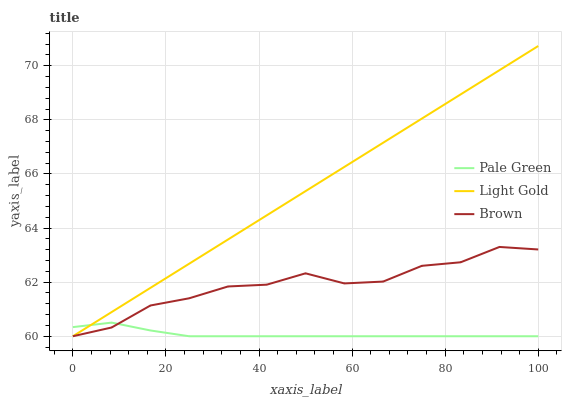Does Pale Green have the minimum area under the curve?
Answer yes or no. Yes. Does Light Gold have the maximum area under the curve?
Answer yes or no. Yes. Does Light Gold have the minimum area under the curve?
Answer yes or no. No. Does Pale Green have the maximum area under the curve?
Answer yes or no. No. Is Light Gold the smoothest?
Answer yes or no. Yes. Is Brown the roughest?
Answer yes or no. Yes. Is Pale Green the smoothest?
Answer yes or no. No. Is Pale Green the roughest?
Answer yes or no. No. Does Brown have the lowest value?
Answer yes or no. Yes. Does Light Gold have the highest value?
Answer yes or no. Yes. Does Pale Green have the highest value?
Answer yes or no. No. Does Light Gold intersect Brown?
Answer yes or no. Yes. Is Light Gold less than Brown?
Answer yes or no. No. Is Light Gold greater than Brown?
Answer yes or no. No. 